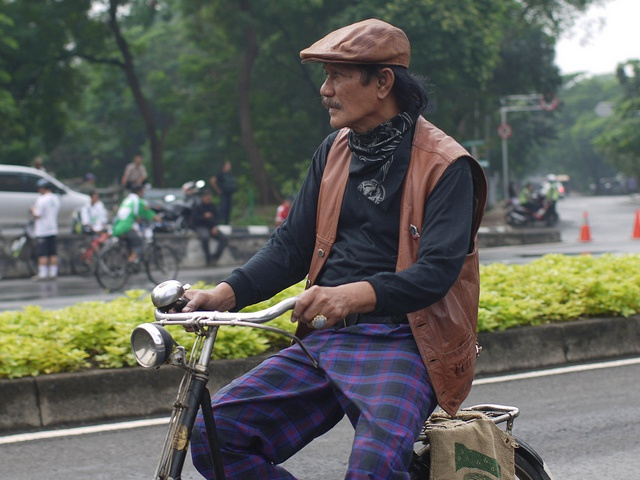Describe the objects in this image and their specific colors. I can see people in darkgreen, black, gray, navy, and maroon tones, bicycle in darkgreen, gray, black, darkgray, and white tones, car in darkgreen, darkgray, gray, lavender, and black tones, bicycle in darkgreen, gray, purple, and black tones, and people in darkgreen, lavender, gray, and darkgray tones in this image. 